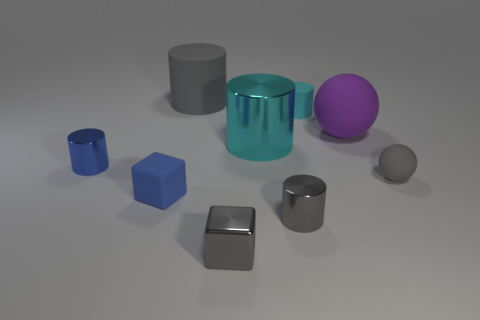Subtract all blue cylinders. How many cylinders are left? 4 Subtract all cyan matte cylinders. How many cylinders are left? 4 Subtract all purple cylinders. Subtract all gray blocks. How many cylinders are left? 5 Add 1 large purple objects. How many objects exist? 10 Subtract all cubes. How many objects are left? 7 Add 7 big cyan shiny things. How many big cyan shiny things exist? 8 Subtract 0 red cylinders. How many objects are left? 9 Subtract all shiny cubes. Subtract all small cyan matte spheres. How many objects are left? 8 Add 4 gray matte cylinders. How many gray matte cylinders are left? 5 